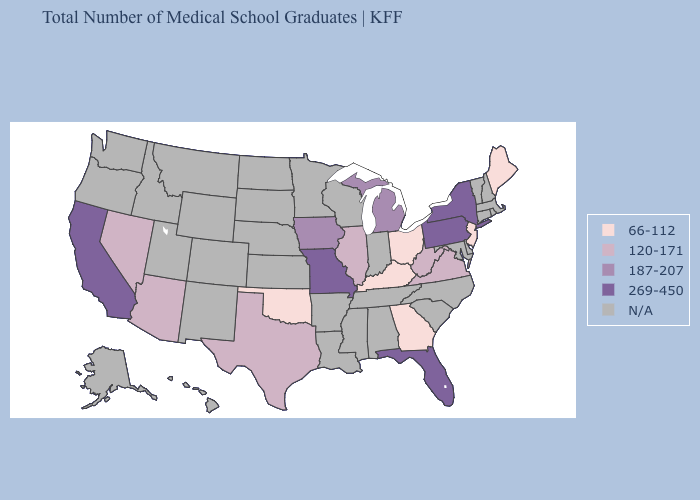What is the highest value in the Northeast ?
Concise answer only. 269-450. What is the lowest value in the MidWest?
Answer briefly. 66-112. Among the states that border Minnesota , which have the highest value?
Short answer required. Iowa. Does the first symbol in the legend represent the smallest category?
Write a very short answer. Yes. Does the map have missing data?
Concise answer only. Yes. Name the states that have a value in the range 269-450?
Be succinct. California, Florida, Missouri, New York, Pennsylvania. Is the legend a continuous bar?
Keep it brief. No. How many symbols are there in the legend?
Concise answer only. 5. Among the states that border Arkansas , does Missouri have the highest value?
Answer briefly. Yes. Which states have the highest value in the USA?
Give a very brief answer. California, Florida, Missouri, New York, Pennsylvania. Which states have the lowest value in the South?
Concise answer only. Georgia, Kentucky, Oklahoma. 